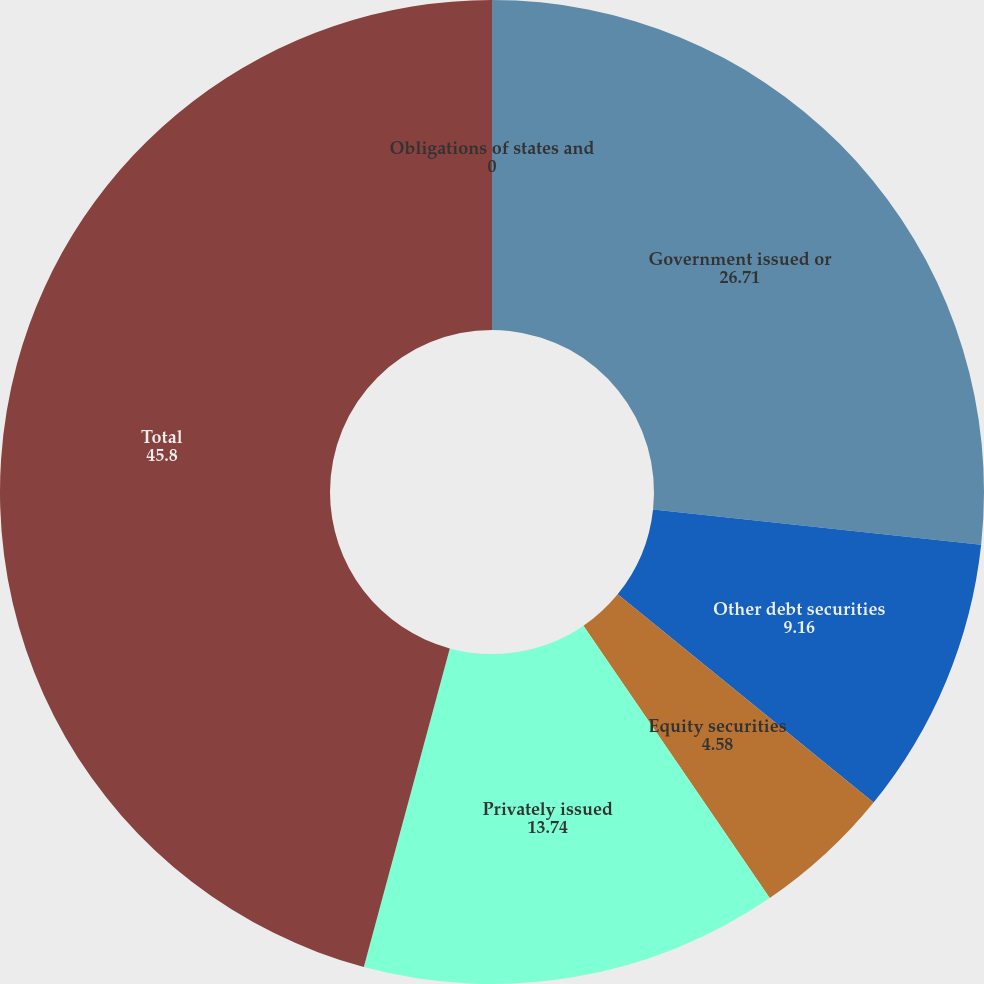Convert chart. <chart><loc_0><loc_0><loc_500><loc_500><pie_chart><fcel>Obligations of states and<fcel>Government issued or<fcel>Other debt securities<fcel>Equity securities<fcel>Privately issued<fcel>Total<nl><fcel>0.0%<fcel>26.71%<fcel>9.16%<fcel>4.58%<fcel>13.74%<fcel>45.8%<nl></chart> 